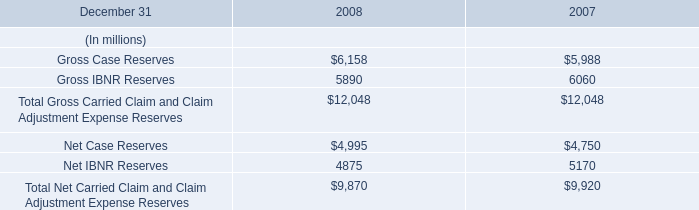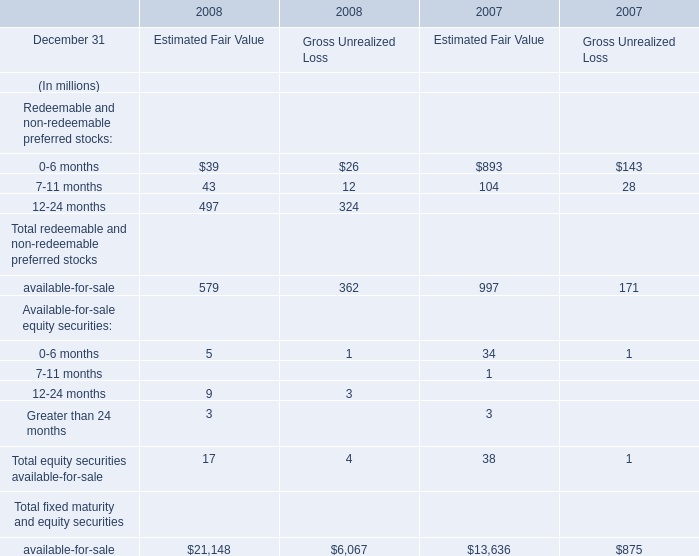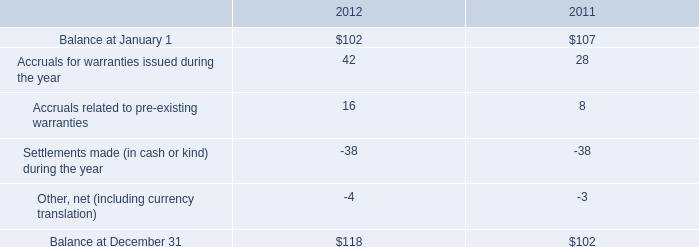what was the percentage change in the company's warranty liability from 2011 to 2012? 
Computations: ((118 - 102) / 102)
Answer: 0.15686. 